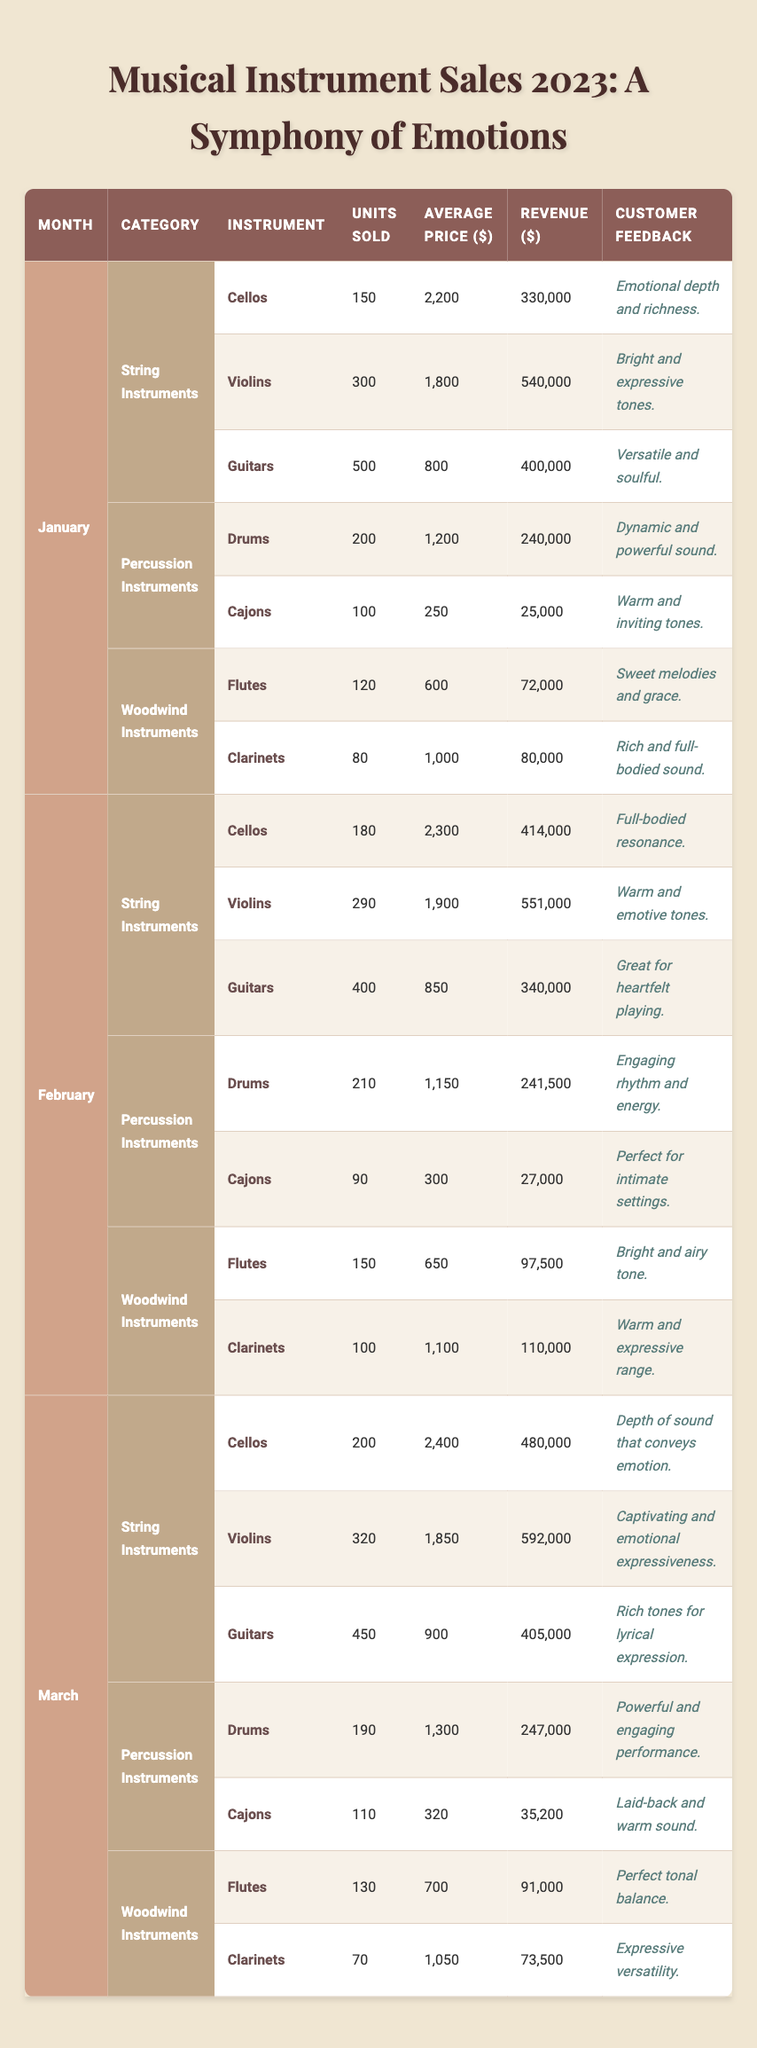What is the total revenue from cello sales in January? In January, the units sold for cellos were 150 and the average price was $2,200. The revenue can be calculated by multiplying these two values: 150 * 2,200 = 330,000.
Answer: 330,000 What was the average price of violins sold in February? The average price of violins in February was $1,900, as stated directly in the table.
Answer: 1,900 Which month had the highest sales for guitars? By comparing the units sold for guitars across January (500), February (400), and March (450), January had the highest sales with 500 units sold.
Answer: January How much more revenue did cellos generate in March compared to February? Cellos generated $480,000 in March and $414,000 in February. The difference is calculated as 480,000 - 414,000 = 66,000.
Answer: 66,000 What is the total units sold for percussion instruments in January? In January, the units sold for drums were 200 and for cajons were 100, totaling 200 + 100 = 300 units sold for percussion instruments.
Answer: 300 Is it true that more flutes were sold in March than in February? In March, 130 flutes were sold, compared to 150 flutes sold in February. This means the statement is false since more flutes were sold in February.
Answer: False What was the customer feedback for the best-selling string instrument in January? The best-selling string instrument in January was guitars with units sold of 500. Their customer feedback is "Versatile and soulful."
Answer: Versatile and soulful How much total revenue was generated from woodwind instruments across all three months? For woodwind instruments, the revenues were $72,000 (January) + $97,500 (February) + $91,000 (March) = $260,500.
Answer: 260,500 Which month had the highest units sold for clarinets? Clarinets sold 80 units in January, 100 in February, and 70 in March, so February had the highest units sold with 100.
Answer: February What is the average revenue from cello sales for the first three months? The revenues for cellos in January, February, and March are $330,000, $414,000, and $480,000, respectively. The average revenue is: (330,000 + 414,000 + 480,000) / 3 = 408,000.
Answer: 408,000 